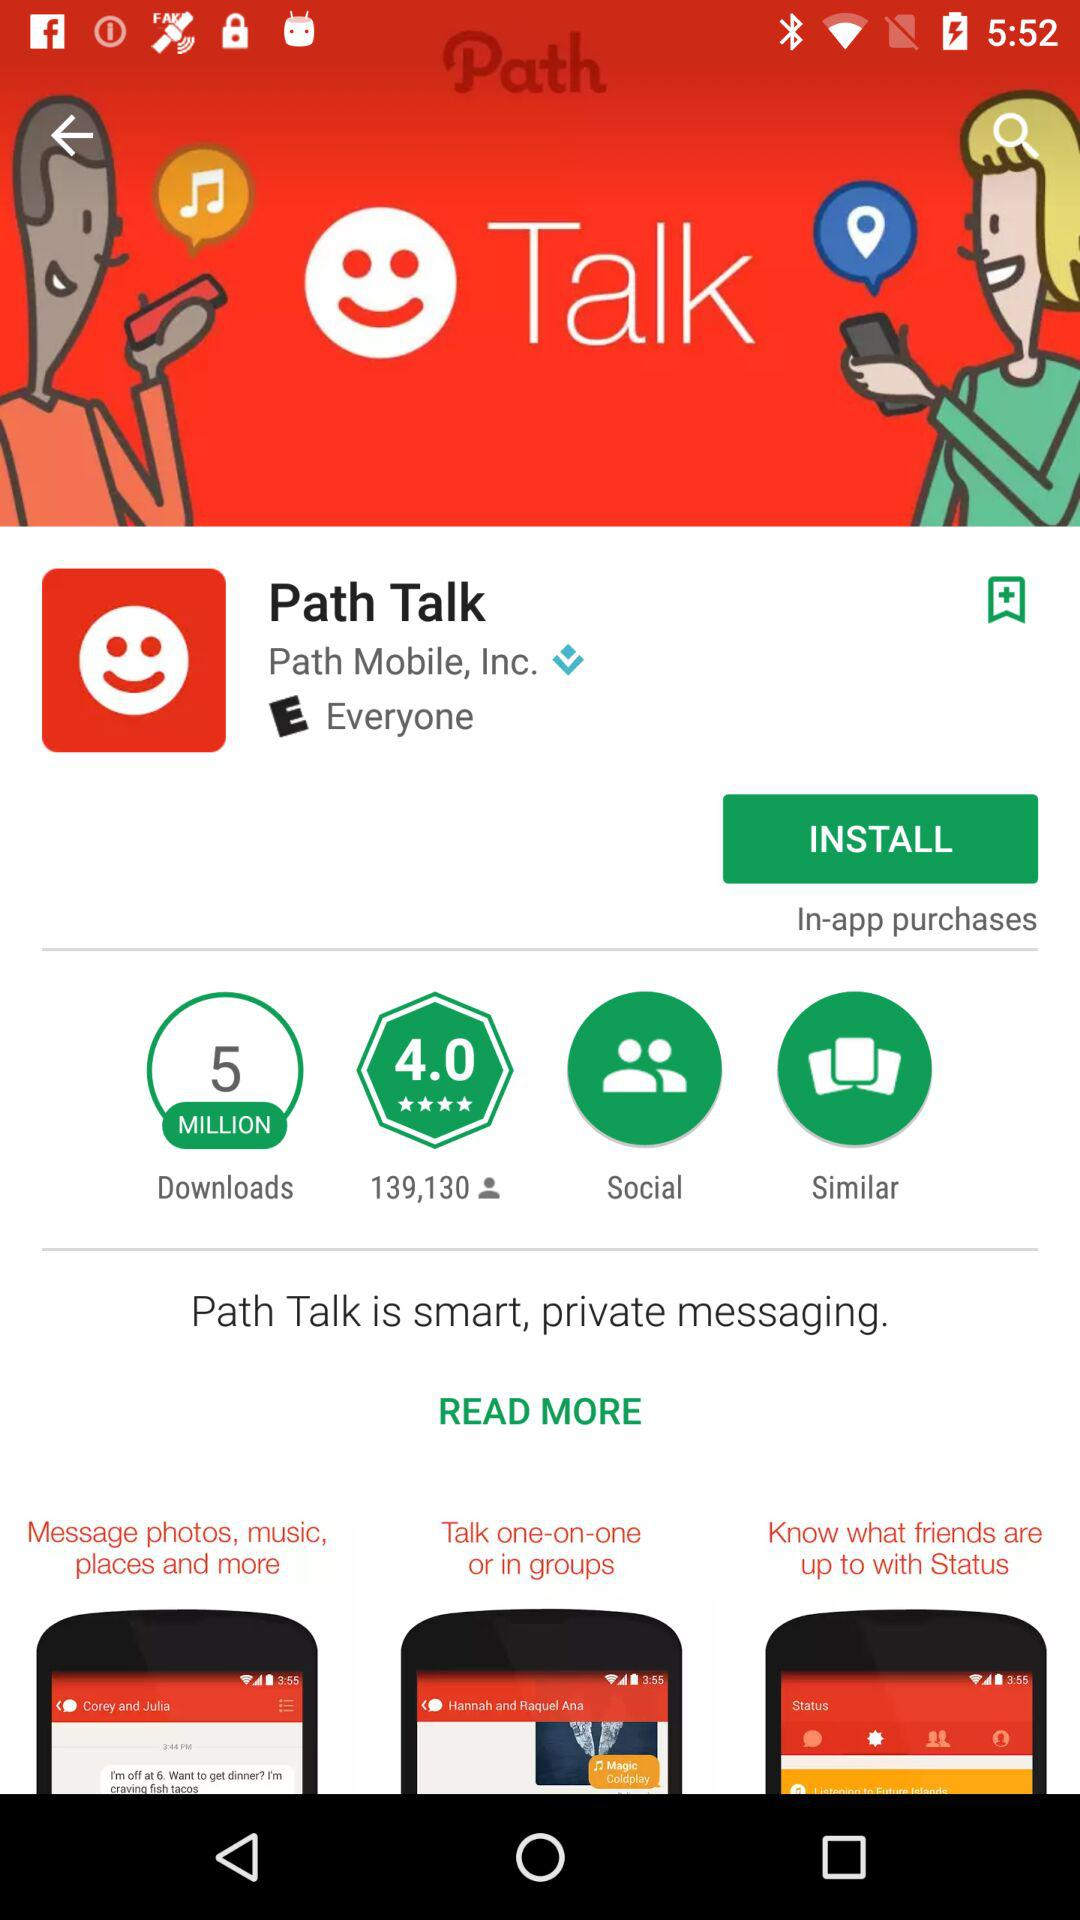How many downloads are there? There are 5 MILLION downloads. 